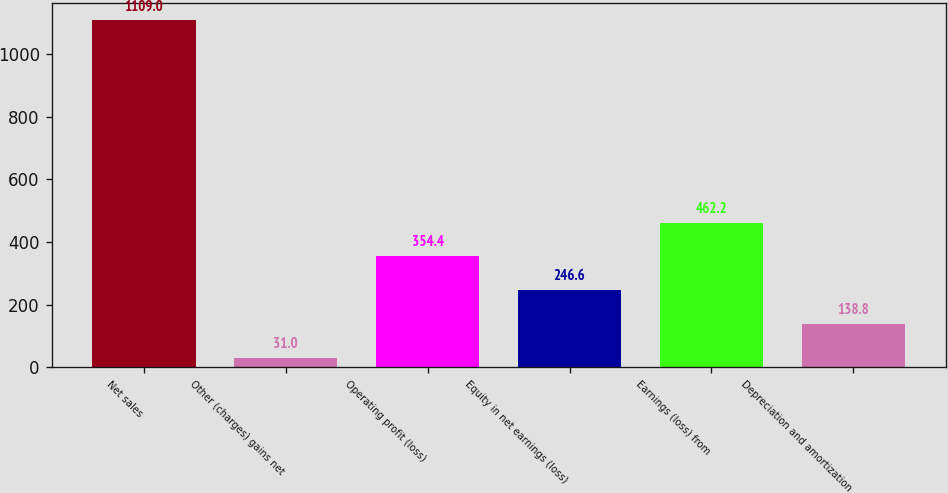Convert chart to OTSL. <chart><loc_0><loc_0><loc_500><loc_500><bar_chart><fcel>Net sales<fcel>Other (charges) gains net<fcel>Operating profit (loss)<fcel>Equity in net earnings (loss)<fcel>Earnings (loss) from<fcel>Depreciation and amortization<nl><fcel>1109<fcel>31<fcel>354.4<fcel>246.6<fcel>462.2<fcel>138.8<nl></chart> 